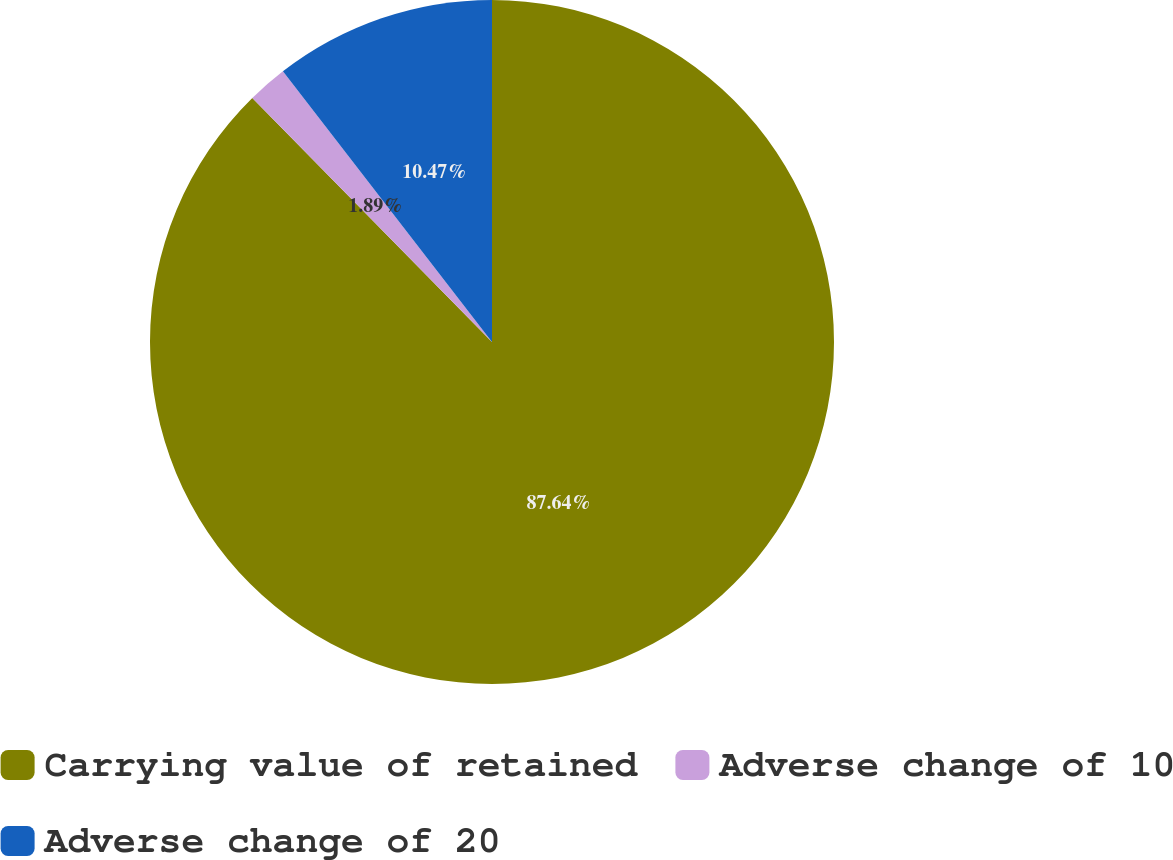<chart> <loc_0><loc_0><loc_500><loc_500><pie_chart><fcel>Carrying value of retained<fcel>Adverse change of 10<fcel>Adverse change of 20<nl><fcel>87.64%<fcel>1.89%<fcel>10.47%<nl></chart> 